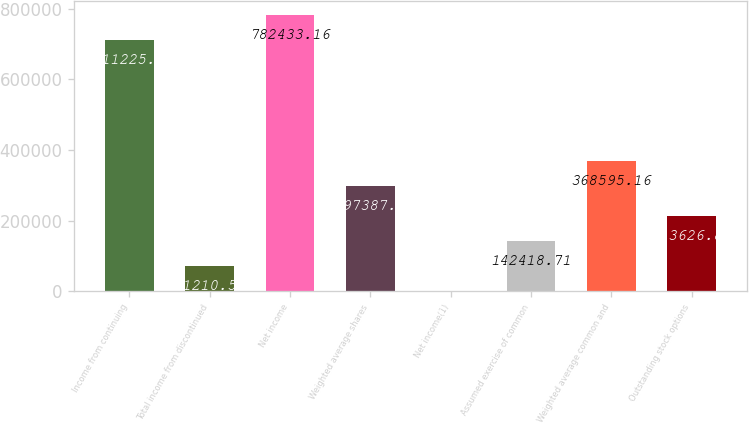<chart> <loc_0><loc_0><loc_500><loc_500><bar_chart><fcel>Income from continuing<fcel>Total income from discontinued<fcel>Net income<fcel>Weighted average shares<fcel>Net income(1)<fcel>Assumed exercise of common<fcel>Weighted average common and<fcel>Outstanding stock options<nl><fcel>711225<fcel>71210.6<fcel>782433<fcel>297387<fcel>2.39<fcel>142419<fcel>368595<fcel>213627<nl></chart> 